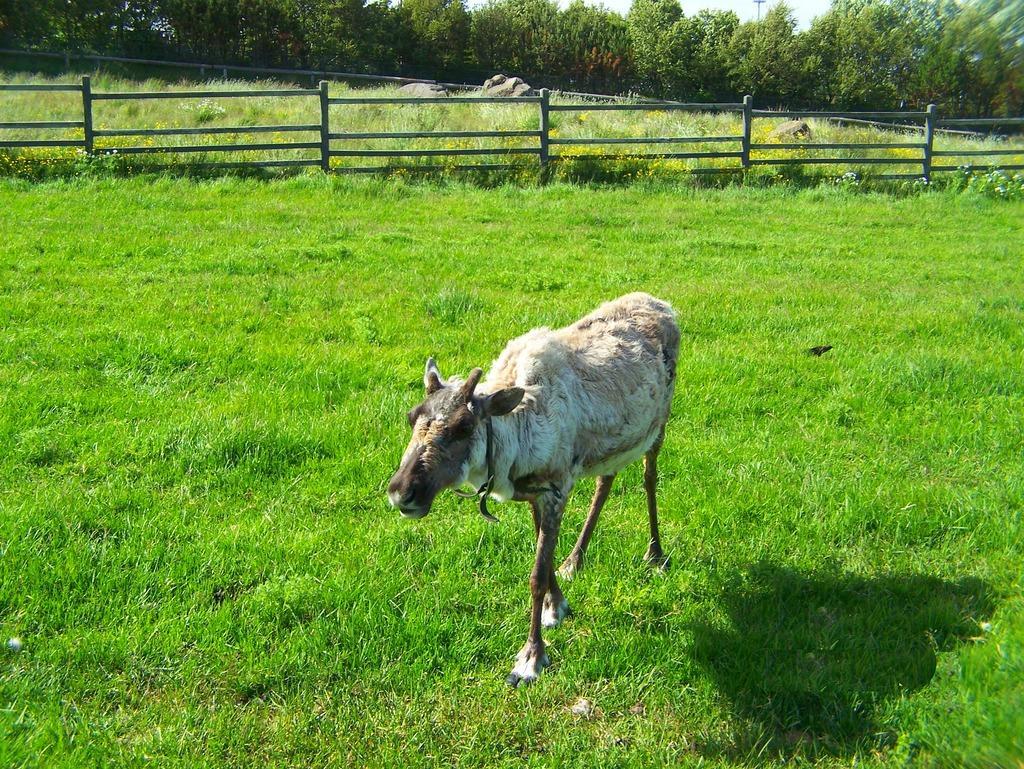Could you give a brief overview of what you see in this image? In this image in the center there is one cow, at the bottom there is grass and in the background there is a fence, grass and some trees. 